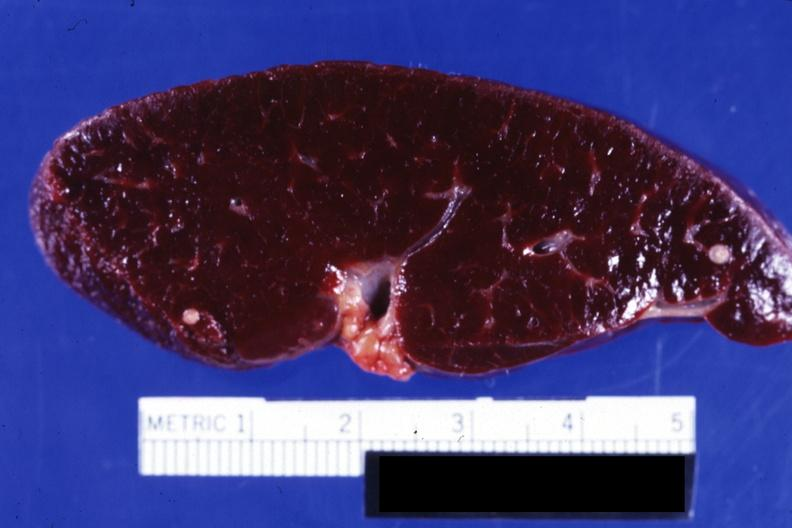where is this part in?
Answer the question using a single word or phrase. Spleen 